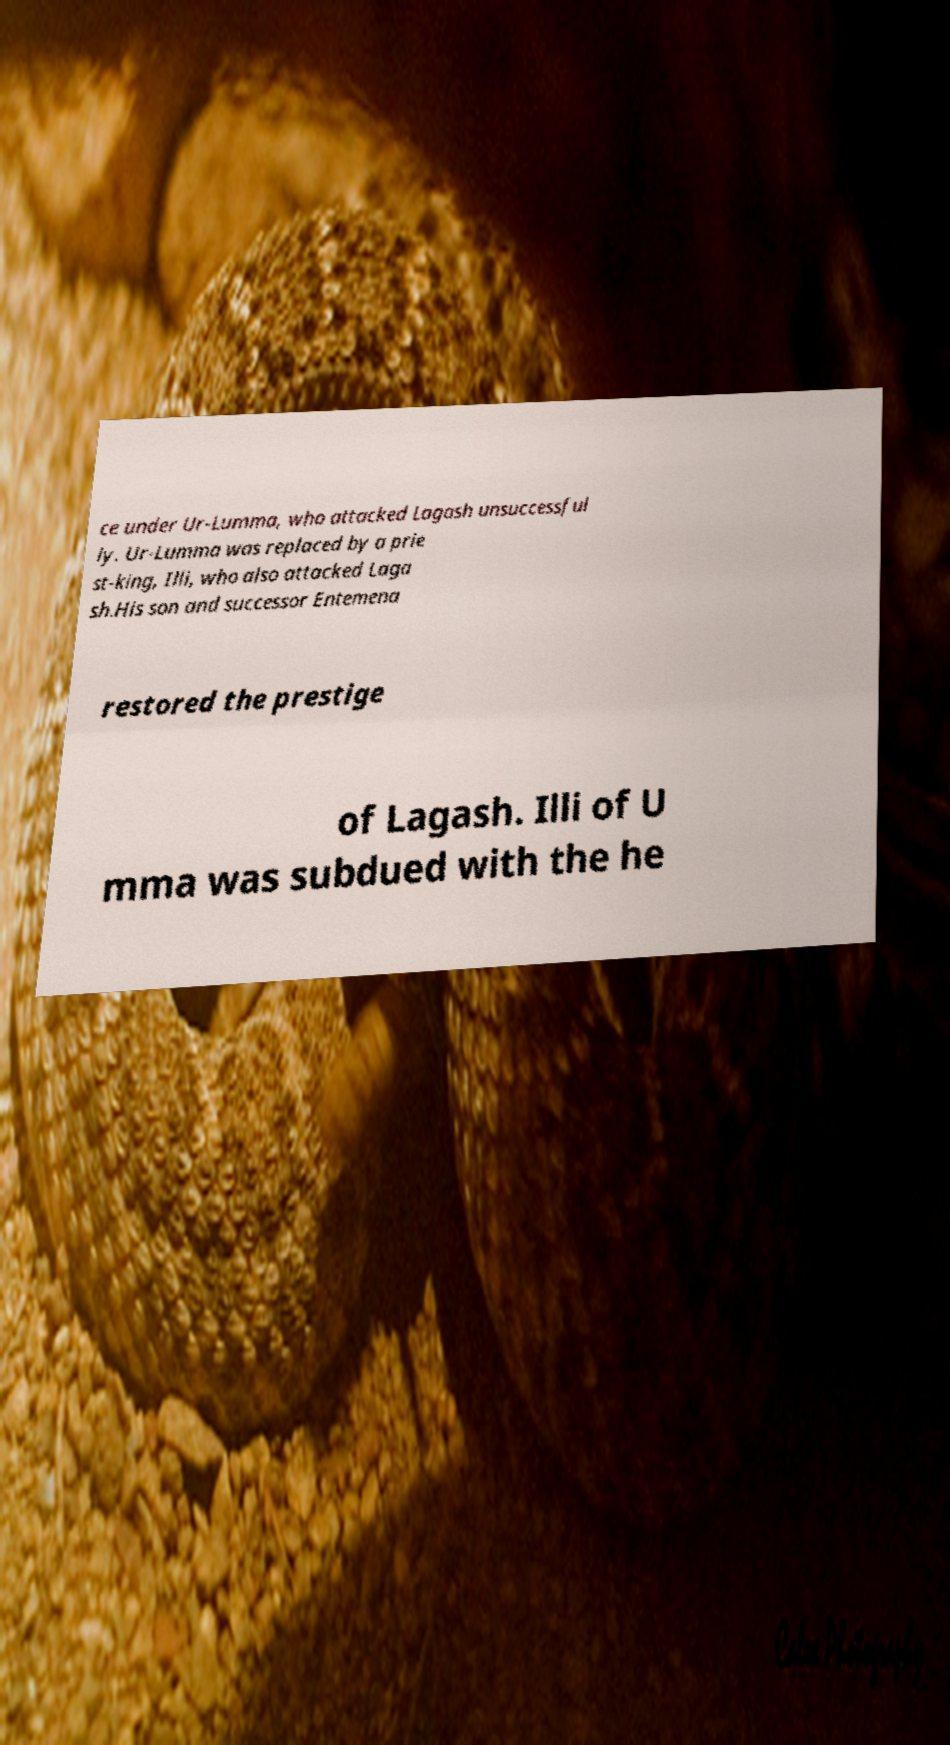Could you extract and type out the text from this image? ce under Ur-Lumma, who attacked Lagash unsuccessful ly. Ur-Lumma was replaced by a prie st-king, Illi, who also attacked Laga sh.His son and successor Entemena restored the prestige of Lagash. Illi of U mma was subdued with the he 